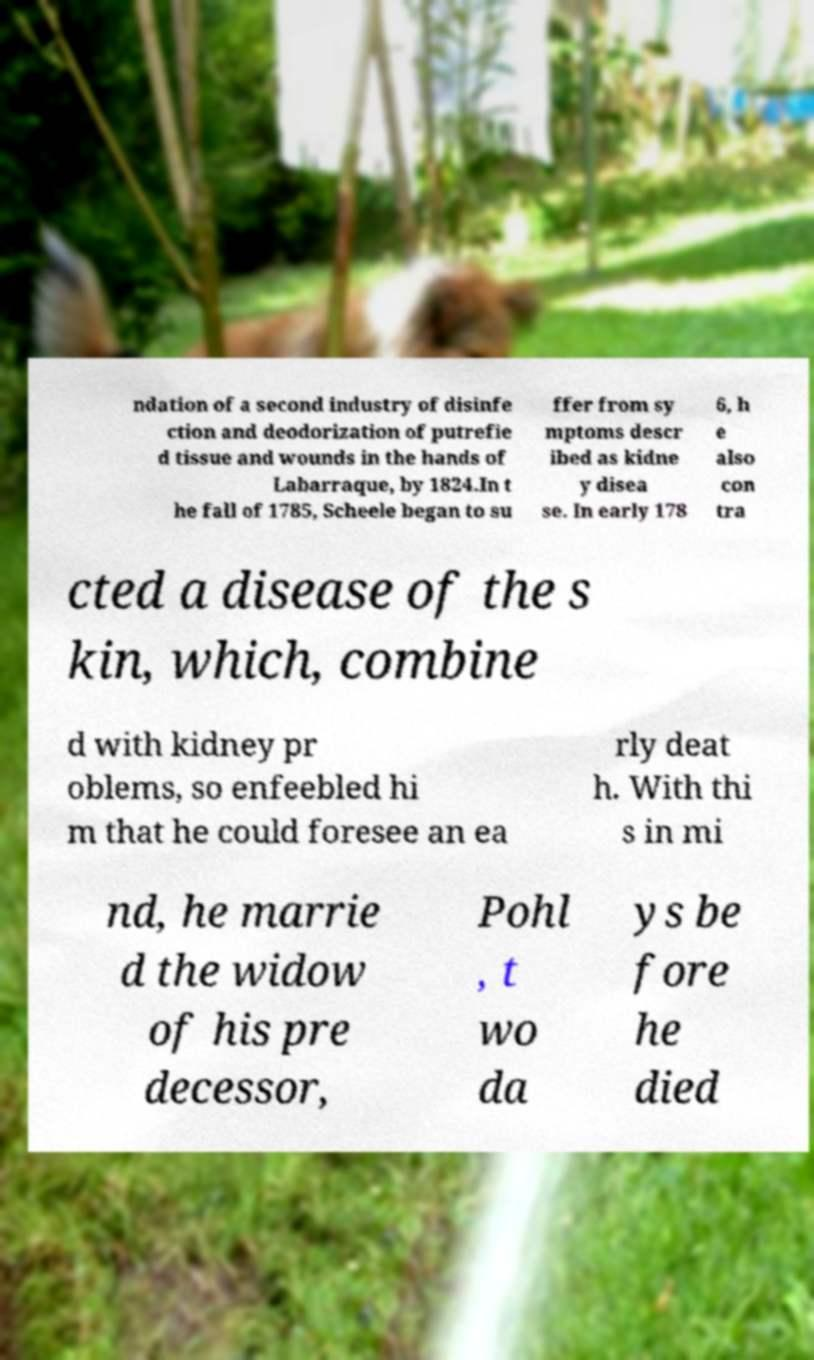For documentation purposes, I need the text within this image transcribed. Could you provide that? ndation of a second industry of disinfe ction and deodorization of putrefie d tissue and wounds in the hands of Labarraque, by 1824.In t he fall of 1785, Scheele began to su ffer from sy mptoms descr ibed as kidne y disea se. In early 178 6, h e also con tra cted a disease of the s kin, which, combine d with kidney pr oblems, so enfeebled hi m that he could foresee an ea rly deat h. With thi s in mi nd, he marrie d the widow of his pre decessor, Pohl , t wo da ys be fore he died 